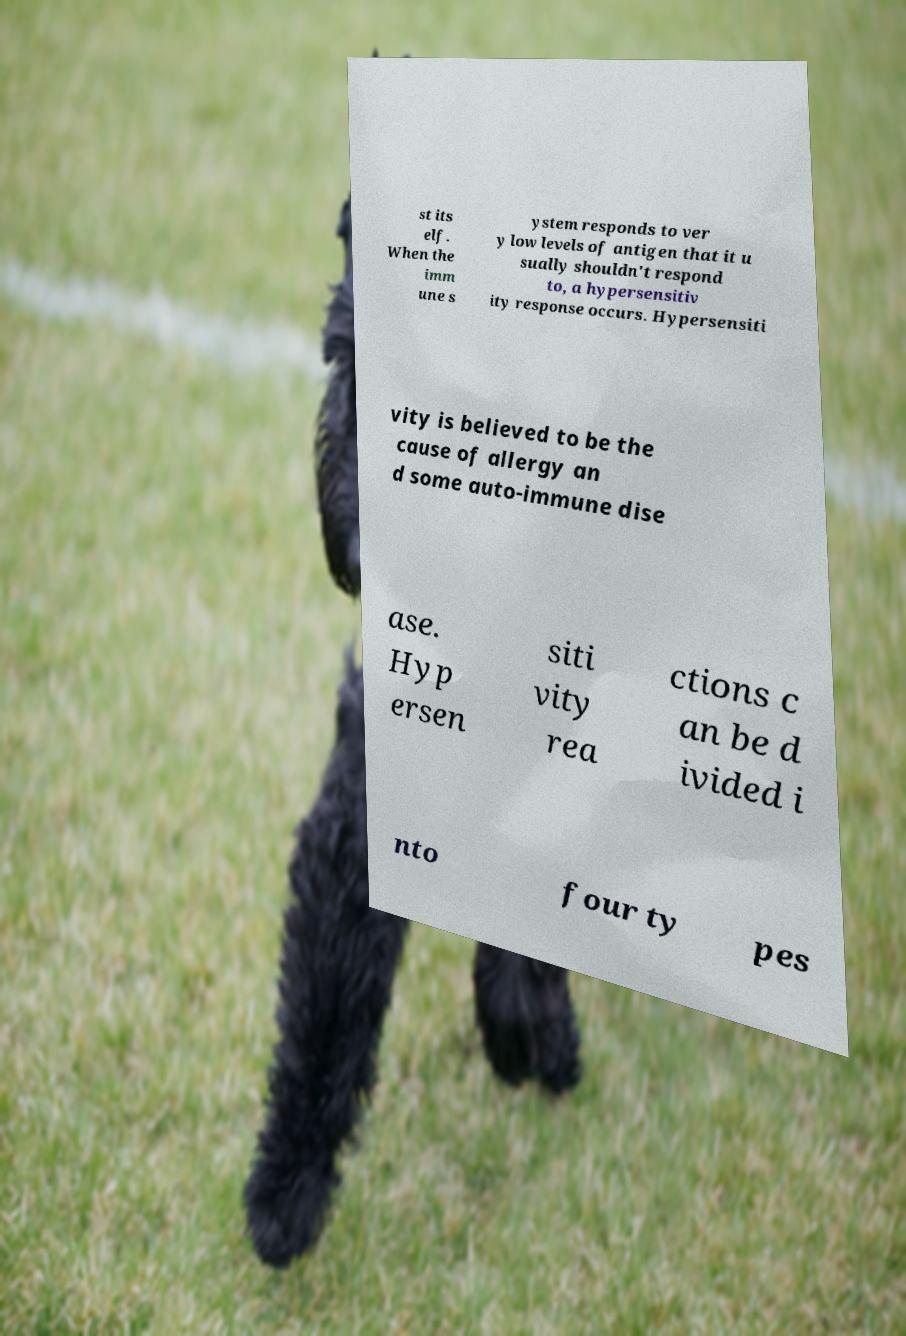Can you read and provide the text displayed in the image?This photo seems to have some interesting text. Can you extract and type it out for me? st its elf. When the imm une s ystem responds to ver y low levels of antigen that it u sually shouldn't respond to, a hypersensitiv ity response occurs. Hypersensiti vity is believed to be the cause of allergy an d some auto-immune dise ase. Hyp ersen siti vity rea ctions c an be d ivided i nto four ty pes 